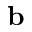<formula> <loc_0><loc_0><loc_500><loc_500>b</formula> 